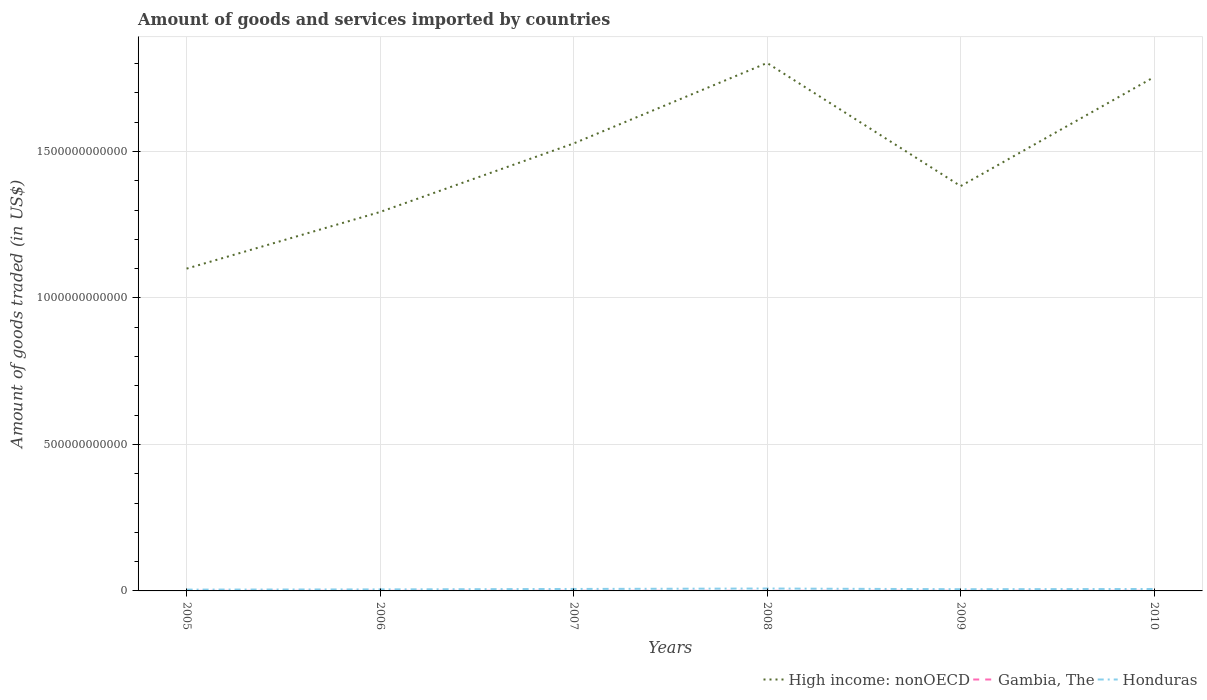Does the line corresponding to Honduras intersect with the line corresponding to Gambia, The?
Your answer should be compact. No. Is the number of lines equal to the number of legend labels?
Your answer should be very brief. Yes. Across all years, what is the maximum total amount of goods and services imported in Honduras?
Offer a very short reply. 4.47e+09. What is the total total amount of goods and services imported in Gambia, The in the graph?
Offer a terse response. 3.93e+05. What is the difference between the highest and the second highest total amount of goods and services imported in High income: nonOECD?
Provide a short and direct response. 7.02e+11. Is the total amount of goods and services imported in Gambia, The strictly greater than the total amount of goods and services imported in Honduras over the years?
Give a very brief answer. Yes. How many lines are there?
Make the answer very short. 3. How many years are there in the graph?
Provide a short and direct response. 6. What is the difference between two consecutive major ticks on the Y-axis?
Your answer should be compact. 5.00e+11. Are the values on the major ticks of Y-axis written in scientific E-notation?
Give a very brief answer. No. Does the graph contain any zero values?
Provide a short and direct response. No. Does the graph contain grids?
Provide a short and direct response. Yes. How many legend labels are there?
Your answer should be very brief. 3. How are the legend labels stacked?
Your answer should be very brief. Horizontal. What is the title of the graph?
Keep it short and to the point. Amount of goods and services imported by countries. Does "Andorra" appear as one of the legend labels in the graph?
Your answer should be compact. No. What is the label or title of the Y-axis?
Make the answer very short. Amount of goods traded (in US$). What is the Amount of goods traded (in US$) in High income: nonOECD in 2005?
Offer a terse response. 1.10e+12. What is the Amount of goods traded (in US$) of Gambia, The in 2005?
Offer a very short reply. 2.23e+08. What is the Amount of goods traded (in US$) of Honduras in 2005?
Provide a succinct answer. 4.47e+09. What is the Amount of goods traded (in US$) in High income: nonOECD in 2006?
Provide a short and direct response. 1.29e+12. What is the Amount of goods traded (in US$) of Gambia, The in 2006?
Provide a succinct answer. 2.22e+08. What is the Amount of goods traded (in US$) of Honduras in 2006?
Provide a short and direct response. 5.22e+09. What is the Amount of goods traded (in US$) in High income: nonOECD in 2007?
Provide a succinct answer. 1.53e+12. What is the Amount of goods traded (in US$) of Gambia, The in 2007?
Your answer should be very brief. 2.80e+08. What is the Amount of goods traded (in US$) in Honduras in 2007?
Provide a short and direct response. 6.71e+09. What is the Amount of goods traded (in US$) of High income: nonOECD in 2008?
Provide a succinct answer. 1.80e+12. What is the Amount of goods traded (in US$) in Gambia, The in 2008?
Offer a terse response. 2.75e+08. What is the Amount of goods traded (in US$) of Honduras in 2008?
Offer a terse response. 8.21e+09. What is the Amount of goods traded (in US$) in High income: nonOECD in 2009?
Provide a succinct answer. 1.38e+12. What is the Amount of goods traded (in US$) of Gambia, The in 2009?
Your response must be concise. 2.60e+08. What is the Amount of goods traded (in US$) of Honduras in 2009?
Offer a very short reply. 5.85e+09. What is the Amount of goods traded (in US$) of High income: nonOECD in 2010?
Your answer should be very brief. 1.75e+12. What is the Amount of goods traded (in US$) of Gambia, The in 2010?
Provide a succinct answer. 2.46e+08. What is the Amount of goods traded (in US$) of Honduras in 2010?
Your answer should be compact. 6.61e+09. Across all years, what is the maximum Amount of goods traded (in US$) in High income: nonOECD?
Ensure brevity in your answer.  1.80e+12. Across all years, what is the maximum Amount of goods traded (in US$) in Gambia, The?
Offer a very short reply. 2.80e+08. Across all years, what is the maximum Amount of goods traded (in US$) of Honduras?
Give a very brief answer. 8.21e+09. Across all years, what is the minimum Amount of goods traded (in US$) of High income: nonOECD?
Ensure brevity in your answer.  1.10e+12. Across all years, what is the minimum Amount of goods traded (in US$) in Gambia, The?
Your answer should be compact. 2.22e+08. Across all years, what is the minimum Amount of goods traded (in US$) of Honduras?
Offer a very short reply. 4.47e+09. What is the total Amount of goods traded (in US$) in High income: nonOECD in the graph?
Offer a very short reply. 8.86e+12. What is the total Amount of goods traded (in US$) of Gambia, The in the graph?
Provide a succinct answer. 1.50e+09. What is the total Amount of goods traded (in US$) in Honduras in the graph?
Keep it short and to the point. 3.71e+1. What is the difference between the Amount of goods traded (in US$) in High income: nonOECD in 2005 and that in 2006?
Your answer should be compact. -1.93e+11. What is the difference between the Amount of goods traded (in US$) in Gambia, The in 2005 and that in 2006?
Your answer should be very brief. 3.93e+05. What is the difference between the Amount of goods traded (in US$) of Honduras in 2005 and that in 2006?
Your answer should be compact. -7.51e+08. What is the difference between the Amount of goods traded (in US$) of High income: nonOECD in 2005 and that in 2007?
Provide a succinct answer. -4.27e+11. What is the difference between the Amount of goods traded (in US$) in Gambia, The in 2005 and that in 2007?
Provide a short and direct response. -5.70e+07. What is the difference between the Amount of goods traded (in US$) of Honduras in 2005 and that in 2007?
Your answer should be very brief. -2.24e+09. What is the difference between the Amount of goods traded (in US$) of High income: nonOECD in 2005 and that in 2008?
Offer a terse response. -7.02e+11. What is the difference between the Amount of goods traded (in US$) of Gambia, The in 2005 and that in 2008?
Your answer should be very brief. -5.19e+07. What is the difference between the Amount of goods traded (in US$) of Honduras in 2005 and that in 2008?
Keep it short and to the point. -3.74e+09. What is the difference between the Amount of goods traded (in US$) in High income: nonOECD in 2005 and that in 2009?
Make the answer very short. -2.82e+11. What is the difference between the Amount of goods traded (in US$) in Gambia, The in 2005 and that in 2009?
Provide a succinct answer. -3.74e+07. What is the difference between the Amount of goods traded (in US$) in Honduras in 2005 and that in 2009?
Ensure brevity in your answer.  -1.38e+09. What is the difference between the Amount of goods traded (in US$) in High income: nonOECD in 2005 and that in 2010?
Your response must be concise. -6.54e+11. What is the difference between the Amount of goods traded (in US$) of Gambia, The in 2005 and that in 2010?
Offer a terse response. -2.32e+07. What is the difference between the Amount of goods traded (in US$) in Honduras in 2005 and that in 2010?
Offer a terse response. -2.14e+09. What is the difference between the Amount of goods traded (in US$) in High income: nonOECD in 2006 and that in 2007?
Your answer should be compact. -2.34e+11. What is the difference between the Amount of goods traded (in US$) in Gambia, The in 2006 and that in 2007?
Provide a succinct answer. -5.74e+07. What is the difference between the Amount of goods traded (in US$) in Honduras in 2006 and that in 2007?
Keep it short and to the point. -1.49e+09. What is the difference between the Amount of goods traded (in US$) in High income: nonOECD in 2006 and that in 2008?
Offer a very short reply. -5.09e+11. What is the difference between the Amount of goods traded (in US$) in Gambia, The in 2006 and that in 2008?
Offer a terse response. -5.23e+07. What is the difference between the Amount of goods traded (in US$) of Honduras in 2006 and that in 2008?
Offer a very short reply. -2.99e+09. What is the difference between the Amount of goods traded (in US$) in High income: nonOECD in 2006 and that in 2009?
Keep it short and to the point. -8.83e+1. What is the difference between the Amount of goods traded (in US$) of Gambia, The in 2006 and that in 2009?
Your answer should be very brief. -3.77e+07. What is the difference between the Amount of goods traded (in US$) of Honduras in 2006 and that in 2009?
Make the answer very short. -6.26e+08. What is the difference between the Amount of goods traded (in US$) in High income: nonOECD in 2006 and that in 2010?
Give a very brief answer. -4.61e+11. What is the difference between the Amount of goods traded (in US$) in Gambia, The in 2006 and that in 2010?
Offer a very short reply. -2.35e+07. What is the difference between the Amount of goods traded (in US$) of Honduras in 2006 and that in 2010?
Ensure brevity in your answer.  -1.39e+09. What is the difference between the Amount of goods traded (in US$) in High income: nonOECD in 2007 and that in 2008?
Your answer should be very brief. -2.75e+11. What is the difference between the Amount of goods traded (in US$) in Gambia, The in 2007 and that in 2008?
Offer a terse response. 5.01e+06. What is the difference between the Amount of goods traded (in US$) in Honduras in 2007 and that in 2008?
Your response must be concise. -1.50e+09. What is the difference between the Amount of goods traded (in US$) of High income: nonOECD in 2007 and that in 2009?
Provide a short and direct response. 1.46e+11. What is the difference between the Amount of goods traded (in US$) in Gambia, The in 2007 and that in 2009?
Offer a very short reply. 1.96e+07. What is the difference between the Amount of goods traded (in US$) of Honduras in 2007 and that in 2009?
Your answer should be compact. 8.62e+08. What is the difference between the Amount of goods traded (in US$) in High income: nonOECD in 2007 and that in 2010?
Provide a succinct answer. -2.27e+11. What is the difference between the Amount of goods traded (in US$) of Gambia, The in 2007 and that in 2010?
Give a very brief answer. 3.38e+07. What is the difference between the Amount of goods traded (in US$) in Honduras in 2007 and that in 2010?
Give a very brief answer. 1.01e+08. What is the difference between the Amount of goods traded (in US$) in High income: nonOECD in 2008 and that in 2009?
Your answer should be very brief. 4.20e+11. What is the difference between the Amount of goods traded (in US$) in Gambia, The in 2008 and that in 2009?
Give a very brief answer. 1.46e+07. What is the difference between the Amount of goods traded (in US$) in Honduras in 2008 and that in 2009?
Your answer should be compact. 2.36e+09. What is the difference between the Amount of goods traded (in US$) in High income: nonOECD in 2008 and that in 2010?
Give a very brief answer. 4.81e+1. What is the difference between the Amount of goods traded (in US$) in Gambia, The in 2008 and that in 2010?
Ensure brevity in your answer.  2.88e+07. What is the difference between the Amount of goods traded (in US$) of Honduras in 2008 and that in 2010?
Offer a very short reply. 1.60e+09. What is the difference between the Amount of goods traded (in US$) in High income: nonOECD in 2009 and that in 2010?
Provide a succinct answer. -3.72e+11. What is the difference between the Amount of goods traded (in US$) of Gambia, The in 2009 and that in 2010?
Keep it short and to the point. 1.42e+07. What is the difference between the Amount of goods traded (in US$) of Honduras in 2009 and that in 2010?
Make the answer very short. -7.61e+08. What is the difference between the Amount of goods traded (in US$) in High income: nonOECD in 2005 and the Amount of goods traded (in US$) in Gambia, The in 2006?
Keep it short and to the point. 1.10e+12. What is the difference between the Amount of goods traded (in US$) of High income: nonOECD in 2005 and the Amount of goods traded (in US$) of Honduras in 2006?
Your answer should be very brief. 1.09e+12. What is the difference between the Amount of goods traded (in US$) of Gambia, The in 2005 and the Amount of goods traded (in US$) of Honduras in 2006?
Give a very brief answer. -5.00e+09. What is the difference between the Amount of goods traded (in US$) in High income: nonOECD in 2005 and the Amount of goods traded (in US$) in Gambia, The in 2007?
Your answer should be very brief. 1.10e+12. What is the difference between the Amount of goods traded (in US$) in High income: nonOECD in 2005 and the Amount of goods traded (in US$) in Honduras in 2007?
Provide a short and direct response. 1.09e+12. What is the difference between the Amount of goods traded (in US$) in Gambia, The in 2005 and the Amount of goods traded (in US$) in Honduras in 2007?
Give a very brief answer. -6.48e+09. What is the difference between the Amount of goods traded (in US$) in High income: nonOECD in 2005 and the Amount of goods traded (in US$) in Gambia, The in 2008?
Provide a succinct answer. 1.10e+12. What is the difference between the Amount of goods traded (in US$) of High income: nonOECD in 2005 and the Amount of goods traded (in US$) of Honduras in 2008?
Your answer should be very brief. 1.09e+12. What is the difference between the Amount of goods traded (in US$) of Gambia, The in 2005 and the Amount of goods traded (in US$) of Honduras in 2008?
Provide a short and direct response. -7.99e+09. What is the difference between the Amount of goods traded (in US$) of High income: nonOECD in 2005 and the Amount of goods traded (in US$) of Gambia, The in 2009?
Your response must be concise. 1.10e+12. What is the difference between the Amount of goods traded (in US$) in High income: nonOECD in 2005 and the Amount of goods traded (in US$) in Honduras in 2009?
Offer a very short reply. 1.09e+12. What is the difference between the Amount of goods traded (in US$) of Gambia, The in 2005 and the Amount of goods traded (in US$) of Honduras in 2009?
Keep it short and to the point. -5.62e+09. What is the difference between the Amount of goods traded (in US$) of High income: nonOECD in 2005 and the Amount of goods traded (in US$) of Gambia, The in 2010?
Offer a very short reply. 1.10e+12. What is the difference between the Amount of goods traded (in US$) in High income: nonOECD in 2005 and the Amount of goods traded (in US$) in Honduras in 2010?
Your answer should be compact. 1.09e+12. What is the difference between the Amount of goods traded (in US$) of Gambia, The in 2005 and the Amount of goods traded (in US$) of Honduras in 2010?
Give a very brief answer. -6.38e+09. What is the difference between the Amount of goods traded (in US$) of High income: nonOECD in 2006 and the Amount of goods traded (in US$) of Gambia, The in 2007?
Your response must be concise. 1.29e+12. What is the difference between the Amount of goods traded (in US$) in High income: nonOECD in 2006 and the Amount of goods traded (in US$) in Honduras in 2007?
Your answer should be very brief. 1.29e+12. What is the difference between the Amount of goods traded (in US$) in Gambia, The in 2006 and the Amount of goods traded (in US$) in Honduras in 2007?
Offer a terse response. -6.48e+09. What is the difference between the Amount of goods traded (in US$) of High income: nonOECD in 2006 and the Amount of goods traded (in US$) of Gambia, The in 2008?
Offer a terse response. 1.29e+12. What is the difference between the Amount of goods traded (in US$) of High income: nonOECD in 2006 and the Amount of goods traded (in US$) of Honduras in 2008?
Make the answer very short. 1.29e+12. What is the difference between the Amount of goods traded (in US$) of Gambia, The in 2006 and the Amount of goods traded (in US$) of Honduras in 2008?
Offer a terse response. -7.99e+09. What is the difference between the Amount of goods traded (in US$) in High income: nonOECD in 2006 and the Amount of goods traded (in US$) in Gambia, The in 2009?
Your answer should be compact. 1.29e+12. What is the difference between the Amount of goods traded (in US$) of High income: nonOECD in 2006 and the Amount of goods traded (in US$) of Honduras in 2009?
Provide a succinct answer. 1.29e+12. What is the difference between the Amount of goods traded (in US$) in Gambia, The in 2006 and the Amount of goods traded (in US$) in Honduras in 2009?
Your answer should be very brief. -5.62e+09. What is the difference between the Amount of goods traded (in US$) of High income: nonOECD in 2006 and the Amount of goods traded (in US$) of Gambia, The in 2010?
Offer a very short reply. 1.29e+12. What is the difference between the Amount of goods traded (in US$) in High income: nonOECD in 2006 and the Amount of goods traded (in US$) in Honduras in 2010?
Offer a terse response. 1.29e+12. What is the difference between the Amount of goods traded (in US$) of Gambia, The in 2006 and the Amount of goods traded (in US$) of Honduras in 2010?
Ensure brevity in your answer.  -6.38e+09. What is the difference between the Amount of goods traded (in US$) of High income: nonOECD in 2007 and the Amount of goods traded (in US$) of Gambia, The in 2008?
Offer a terse response. 1.53e+12. What is the difference between the Amount of goods traded (in US$) in High income: nonOECD in 2007 and the Amount of goods traded (in US$) in Honduras in 2008?
Give a very brief answer. 1.52e+12. What is the difference between the Amount of goods traded (in US$) of Gambia, The in 2007 and the Amount of goods traded (in US$) of Honduras in 2008?
Give a very brief answer. -7.93e+09. What is the difference between the Amount of goods traded (in US$) in High income: nonOECD in 2007 and the Amount of goods traded (in US$) in Gambia, The in 2009?
Offer a very short reply. 1.53e+12. What is the difference between the Amount of goods traded (in US$) of High income: nonOECD in 2007 and the Amount of goods traded (in US$) of Honduras in 2009?
Your answer should be very brief. 1.52e+12. What is the difference between the Amount of goods traded (in US$) in Gambia, The in 2007 and the Amount of goods traded (in US$) in Honduras in 2009?
Provide a short and direct response. -5.57e+09. What is the difference between the Amount of goods traded (in US$) in High income: nonOECD in 2007 and the Amount of goods traded (in US$) in Gambia, The in 2010?
Offer a terse response. 1.53e+12. What is the difference between the Amount of goods traded (in US$) of High income: nonOECD in 2007 and the Amount of goods traded (in US$) of Honduras in 2010?
Ensure brevity in your answer.  1.52e+12. What is the difference between the Amount of goods traded (in US$) of Gambia, The in 2007 and the Amount of goods traded (in US$) of Honduras in 2010?
Your answer should be compact. -6.33e+09. What is the difference between the Amount of goods traded (in US$) in High income: nonOECD in 2008 and the Amount of goods traded (in US$) in Gambia, The in 2009?
Offer a terse response. 1.80e+12. What is the difference between the Amount of goods traded (in US$) in High income: nonOECD in 2008 and the Amount of goods traded (in US$) in Honduras in 2009?
Provide a succinct answer. 1.80e+12. What is the difference between the Amount of goods traded (in US$) in Gambia, The in 2008 and the Amount of goods traded (in US$) in Honduras in 2009?
Provide a succinct answer. -5.57e+09. What is the difference between the Amount of goods traded (in US$) in High income: nonOECD in 2008 and the Amount of goods traded (in US$) in Gambia, The in 2010?
Ensure brevity in your answer.  1.80e+12. What is the difference between the Amount of goods traded (in US$) in High income: nonOECD in 2008 and the Amount of goods traded (in US$) in Honduras in 2010?
Your response must be concise. 1.80e+12. What is the difference between the Amount of goods traded (in US$) of Gambia, The in 2008 and the Amount of goods traded (in US$) of Honduras in 2010?
Make the answer very short. -6.33e+09. What is the difference between the Amount of goods traded (in US$) of High income: nonOECD in 2009 and the Amount of goods traded (in US$) of Gambia, The in 2010?
Provide a succinct answer. 1.38e+12. What is the difference between the Amount of goods traded (in US$) in High income: nonOECD in 2009 and the Amount of goods traded (in US$) in Honduras in 2010?
Make the answer very short. 1.38e+12. What is the difference between the Amount of goods traded (in US$) in Gambia, The in 2009 and the Amount of goods traded (in US$) in Honduras in 2010?
Ensure brevity in your answer.  -6.35e+09. What is the average Amount of goods traded (in US$) in High income: nonOECD per year?
Your answer should be very brief. 1.48e+12. What is the average Amount of goods traded (in US$) in Gambia, The per year?
Keep it short and to the point. 2.51e+08. What is the average Amount of goods traded (in US$) of Honduras per year?
Offer a very short reply. 6.18e+09. In the year 2005, what is the difference between the Amount of goods traded (in US$) in High income: nonOECD and Amount of goods traded (in US$) in Gambia, The?
Offer a terse response. 1.10e+12. In the year 2005, what is the difference between the Amount of goods traded (in US$) in High income: nonOECD and Amount of goods traded (in US$) in Honduras?
Keep it short and to the point. 1.10e+12. In the year 2005, what is the difference between the Amount of goods traded (in US$) in Gambia, The and Amount of goods traded (in US$) in Honduras?
Offer a terse response. -4.25e+09. In the year 2006, what is the difference between the Amount of goods traded (in US$) in High income: nonOECD and Amount of goods traded (in US$) in Gambia, The?
Ensure brevity in your answer.  1.29e+12. In the year 2006, what is the difference between the Amount of goods traded (in US$) of High income: nonOECD and Amount of goods traded (in US$) of Honduras?
Your answer should be compact. 1.29e+12. In the year 2006, what is the difference between the Amount of goods traded (in US$) in Gambia, The and Amount of goods traded (in US$) in Honduras?
Your response must be concise. -5.00e+09. In the year 2007, what is the difference between the Amount of goods traded (in US$) in High income: nonOECD and Amount of goods traded (in US$) in Gambia, The?
Provide a succinct answer. 1.53e+12. In the year 2007, what is the difference between the Amount of goods traded (in US$) in High income: nonOECD and Amount of goods traded (in US$) in Honduras?
Your answer should be very brief. 1.52e+12. In the year 2007, what is the difference between the Amount of goods traded (in US$) of Gambia, The and Amount of goods traded (in US$) of Honduras?
Ensure brevity in your answer.  -6.43e+09. In the year 2008, what is the difference between the Amount of goods traded (in US$) in High income: nonOECD and Amount of goods traded (in US$) in Gambia, The?
Provide a short and direct response. 1.80e+12. In the year 2008, what is the difference between the Amount of goods traded (in US$) of High income: nonOECD and Amount of goods traded (in US$) of Honduras?
Keep it short and to the point. 1.79e+12. In the year 2008, what is the difference between the Amount of goods traded (in US$) of Gambia, The and Amount of goods traded (in US$) of Honduras?
Provide a short and direct response. -7.93e+09. In the year 2009, what is the difference between the Amount of goods traded (in US$) of High income: nonOECD and Amount of goods traded (in US$) of Gambia, The?
Keep it short and to the point. 1.38e+12. In the year 2009, what is the difference between the Amount of goods traded (in US$) in High income: nonOECD and Amount of goods traded (in US$) in Honduras?
Make the answer very short. 1.38e+12. In the year 2009, what is the difference between the Amount of goods traded (in US$) of Gambia, The and Amount of goods traded (in US$) of Honduras?
Keep it short and to the point. -5.59e+09. In the year 2010, what is the difference between the Amount of goods traded (in US$) of High income: nonOECD and Amount of goods traded (in US$) of Gambia, The?
Give a very brief answer. 1.75e+12. In the year 2010, what is the difference between the Amount of goods traded (in US$) in High income: nonOECD and Amount of goods traded (in US$) in Honduras?
Ensure brevity in your answer.  1.75e+12. In the year 2010, what is the difference between the Amount of goods traded (in US$) of Gambia, The and Amount of goods traded (in US$) of Honduras?
Give a very brief answer. -6.36e+09. What is the ratio of the Amount of goods traded (in US$) of High income: nonOECD in 2005 to that in 2006?
Provide a short and direct response. 0.85. What is the ratio of the Amount of goods traded (in US$) in Honduras in 2005 to that in 2006?
Your answer should be compact. 0.86. What is the ratio of the Amount of goods traded (in US$) in High income: nonOECD in 2005 to that in 2007?
Keep it short and to the point. 0.72. What is the ratio of the Amount of goods traded (in US$) of Gambia, The in 2005 to that in 2007?
Your answer should be compact. 0.8. What is the ratio of the Amount of goods traded (in US$) in Honduras in 2005 to that in 2007?
Give a very brief answer. 0.67. What is the ratio of the Amount of goods traded (in US$) of High income: nonOECD in 2005 to that in 2008?
Make the answer very short. 0.61. What is the ratio of the Amount of goods traded (in US$) of Gambia, The in 2005 to that in 2008?
Your answer should be compact. 0.81. What is the ratio of the Amount of goods traded (in US$) of Honduras in 2005 to that in 2008?
Keep it short and to the point. 0.54. What is the ratio of the Amount of goods traded (in US$) of High income: nonOECD in 2005 to that in 2009?
Keep it short and to the point. 0.8. What is the ratio of the Amount of goods traded (in US$) of Gambia, The in 2005 to that in 2009?
Ensure brevity in your answer.  0.86. What is the ratio of the Amount of goods traded (in US$) in Honduras in 2005 to that in 2009?
Give a very brief answer. 0.76. What is the ratio of the Amount of goods traded (in US$) in High income: nonOECD in 2005 to that in 2010?
Keep it short and to the point. 0.63. What is the ratio of the Amount of goods traded (in US$) in Gambia, The in 2005 to that in 2010?
Offer a very short reply. 0.91. What is the ratio of the Amount of goods traded (in US$) in Honduras in 2005 to that in 2010?
Provide a short and direct response. 0.68. What is the ratio of the Amount of goods traded (in US$) of High income: nonOECD in 2006 to that in 2007?
Keep it short and to the point. 0.85. What is the ratio of the Amount of goods traded (in US$) of Gambia, The in 2006 to that in 2007?
Provide a succinct answer. 0.79. What is the ratio of the Amount of goods traded (in US$) in Honduras in 2006 to that in 2007?
Your answer should be compact. 0.78. What is the ratio of the Amount of goods traded (in US$) in High income: nonOECD in 2006 to that in 2008?
Offer a very short reply. 0.72. What is the ratio of the Amount of goods traded (in US$) of Gambia, The in 2006 to that in 2008?
Offer a terse response. 0.81. What is the ratio of the Amount of goods traded (in US$) in Honduras in 2006 to that in 2008?
Provide a succinct answer. 0.64. What is the ratio of the Amount of goods traded (in US$) of High income: nonOECD in 2006 to that in 2009?
Your answer should be very brief. 0.94. What is the ratio of the Amount of goods traded (in US$) in Gambia, The in 2006 to that in 2009?
Your response must be concise. 0.85. What is the ratio of the Amount of goods traded (in US$) of Honduras in 2006 to that in 2009?
Your response must be concise. 0.89. What is the ratio of the Amount of goods traded (in US$) in High income: nonOECD in 2006 to that in 2010?
Offer a terse response. 0.74. What is the ratio of the Amount of goods traded (in US$) in Gambia, The in 2006 to that in 2010?
Your answer should be compact. 0.9. What is the ratio of the Amount of goods traded (in US$) in Honduras in 2006 to that in 2010?
Provide a short and direct response. 0.79. What is the ratio of the Amount of goods traded (in US$) in High income: nonOECD in 2007 to that in 2008?
Provide a short and direct response. 0.85. What is the ratio of the Amount of goods traded (in US$) in Gambia, The in 2007 to that in 2008?
Your response must be concise. 1.02. What is the ratio of the Amount of goods traded (in US$) of Honduras in 2007 to that in 2008?
Provide a short and direct response. 0.82. What is the ratio of the Amount of goods traded (in US$) of High income: nonOECD in 2007 to that in 2009?
Offer a very short reply. 1.11. What is the ratio of the Amount of goods traded (in US$) of Gambia, The in 2007 to that in 2009?
Offer a very short reply. 1.08. What is the ratio of the Amount of goods traded (in US$) in Honduras in 2007 to that in 2009?
Your response must be concise. 1.15. What is the ratio of the Amount of goods traded (in US$) of High income: nonOECD in 2007 to that in 2010?
Your answer should be compact. 0.87. What is the ratio of the Amount of goods traded (in US$) of Gambia, The in 2007 to that in 2010?
Offer a very short reply. 1.14. What is the ratio of the Amount of goods traded (in US$) in Honduras in 2007 to that in 2010?
Give a very brief answer. 1.02. What is the ratio of the Amount of goods traded (in US$) of High income: nonOECD in 2008 to that in 2009?
Give a very brief answer. 1.3. What is the ratio of the Amount of goods traded (in US$) in Gambia, The in 2008 to that in 2009?
Make the answer very short. 1.06. What is the ratio of the Amount of goods traded (in US$) in Honduras in 2008 to that in 2009?
Provide a short and direct response. 1.4. What is the ratio of the Amount of goods traded (in US$) of High income: nonOECD in 2008 to that in 2010?
Your answer should be compact. 1.03. What is the ratio of the Amount of goods traded (in US$) in Gambia, The in 2008 to that in 2010?
Keep it short and to the point. 1.12. What is the ratio of the Amount of goods traded (in US$) of Honduras in 2008 to that in 2010?
Ensure brevity in your answer.  1.24. What is the ratio of the Amount of goods traded (in US$) of High income: nonOECD in 2009 to that in 2010?
Your answer should be very brief. 0.79. What is the ratio of the Amount of goods traded (in US$) of Gambia, The in 2009 to that in 2010?
Ensure brevity in your answer.  1.06. What is the ratio of the Amount of goods traded (in US$) of Honduras in 2009 to that in 2010?
Your response must be concise. 0.88. What is the difference between the highest and the second highest Amount of goods traded (in US$) of High income: nonOECD?
Offer a terse response. 4.81e+1. What is the difference between the highest and the second highest Amount of goods traded (in US$) of Gambia, The?
Your response must be concise. 5.01e+06. What is the difference between the highest and the second highest Amount of goods traded (in US$) of Honduras?
Make the answer very short. 1.50e+09. What is the difference between the highest and the lowest Amount of goods traded (in US$) in High income: nonOECD?
Offer a terse response. 7.02e+11. What is the difference between the highest and the lowest Amount of goods traded (in US$) in Gambia, The?
Keep it short and to the point. 5.74e+07. What is the difference between the highest and the lowest Amount of goods traded (in US$) in Honduras?
Give a very brief answer. 3.74e+09. 